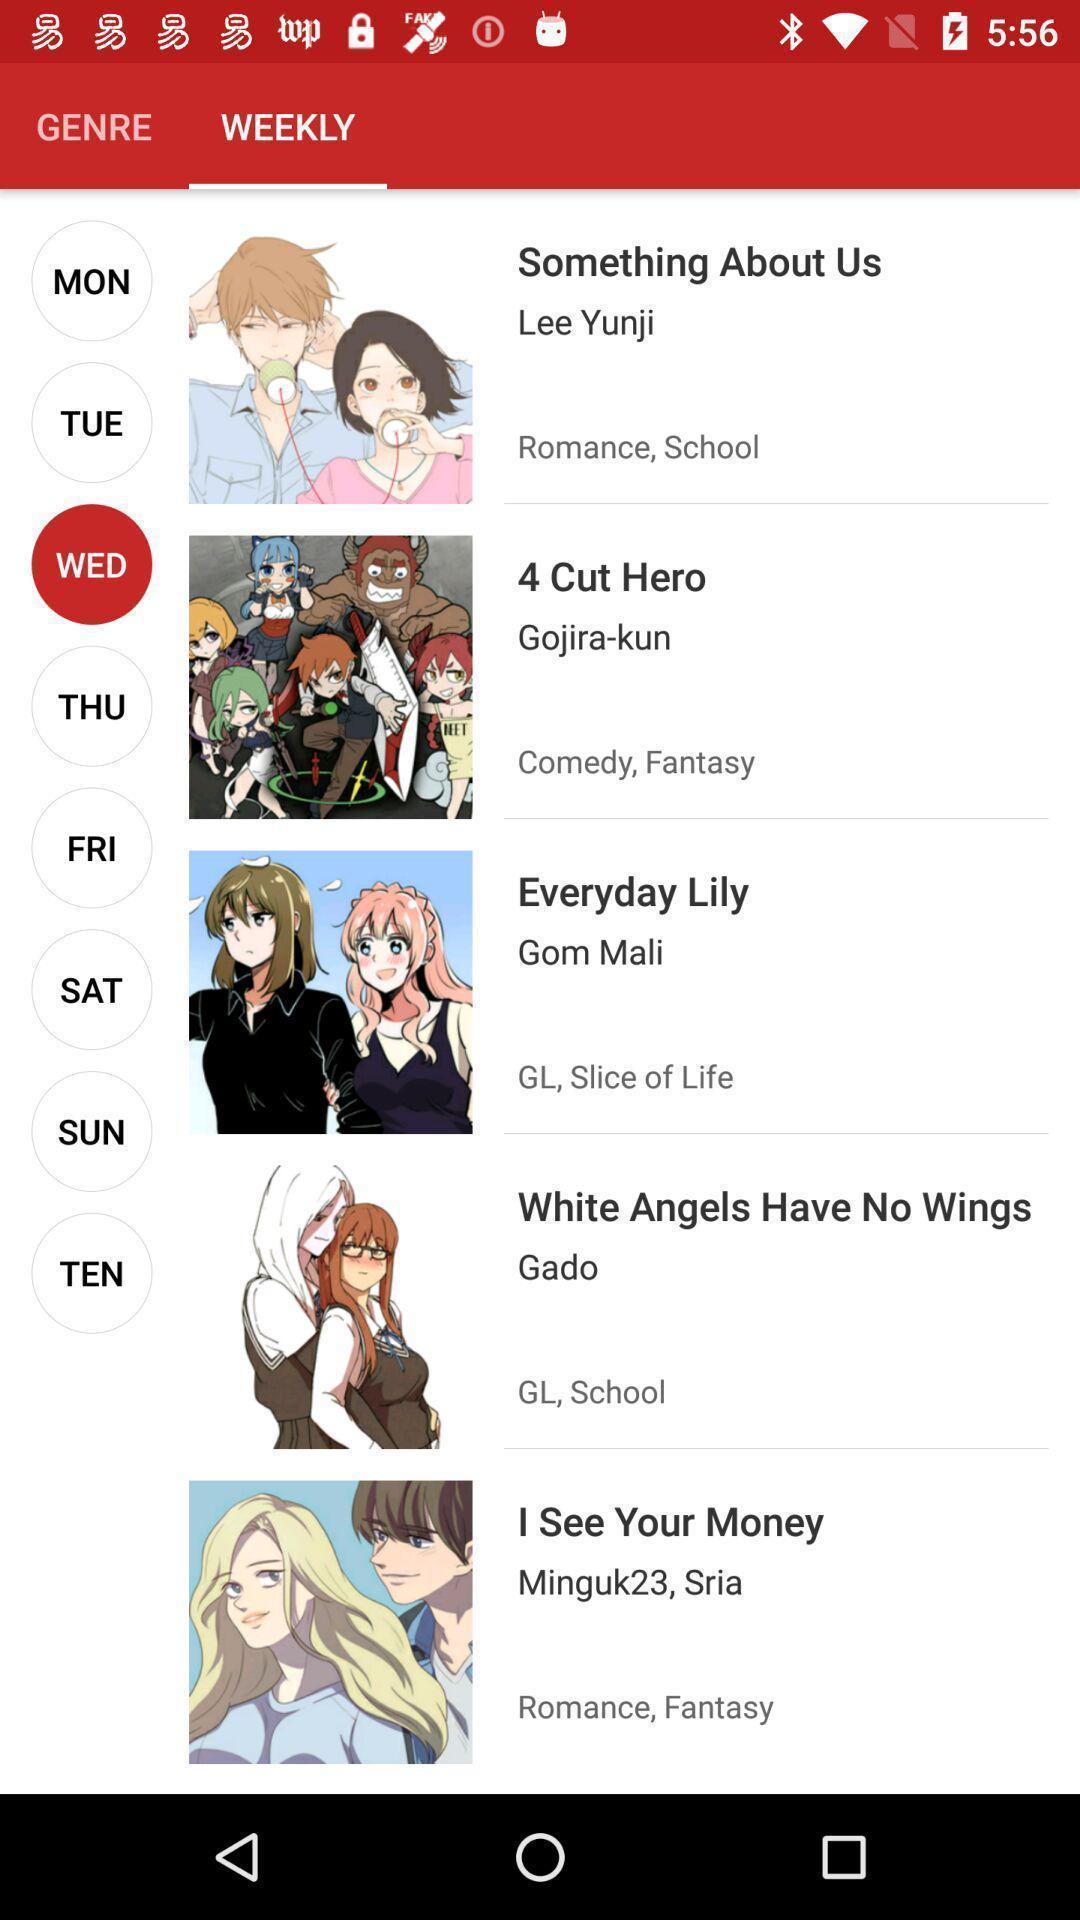What details can you identify in this image? Page displaying weekly genres. 